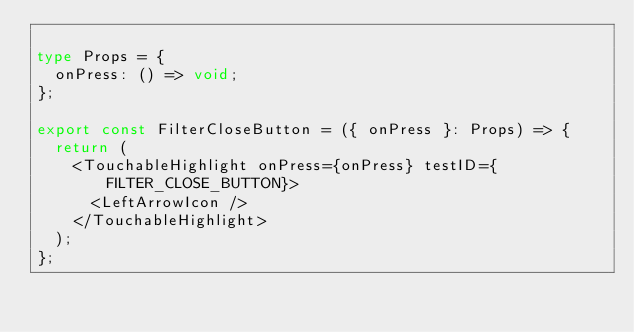<code> <loc_0><loc_0><loc_500><loc_500><_TypeScript_>
type Props = {
  onPress: () => void;
};

export const FilterCloseButton = ({ onPress }: Props) => {
  return (
    <TouchableHighlight onPress={onPress} testID={FILTER_CLOSE_BUTTON}>
      <LeftArrowIcon />
    </TouchableHighlight>
  );
};
</code> 